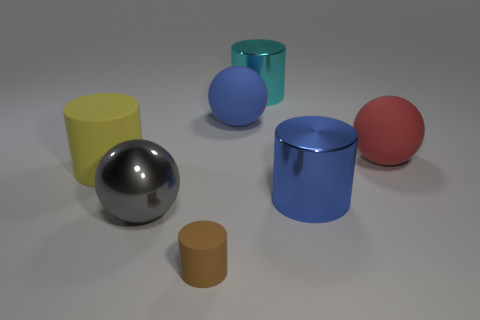Subtract all big matte cylinders. How many cylinders are left? 3 Add 3 yellow matte objects. How many objects exist? 10 Subtract all cyan cylinders. How many cylinders are left? 3 Subtract 2 spheres. How many spheres are left? 1 Add 3 gray shiny things. How many gray shiny things exist? 4 Subtract 0 green balls. How many objects are left? 7 Subtract all cylinders. How many objects are left? 3 Subtract all yellow cylinders. Subtract all brown balls. How many cylinders are left? 3 Subtract all large brown metal objects. Subtract all large blue metallic cylinders. How many objects are left? 6 Add 6 large metal cylinders. How many large metal cylinders are left? 8 